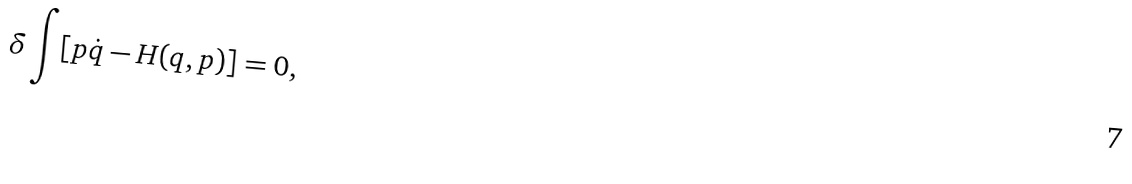<formula> <loc_0><loc_0><loc_500><loc_500>\delta \int [ p \dot { q } - H ( q , p ) ] = 0 ,</formula> 